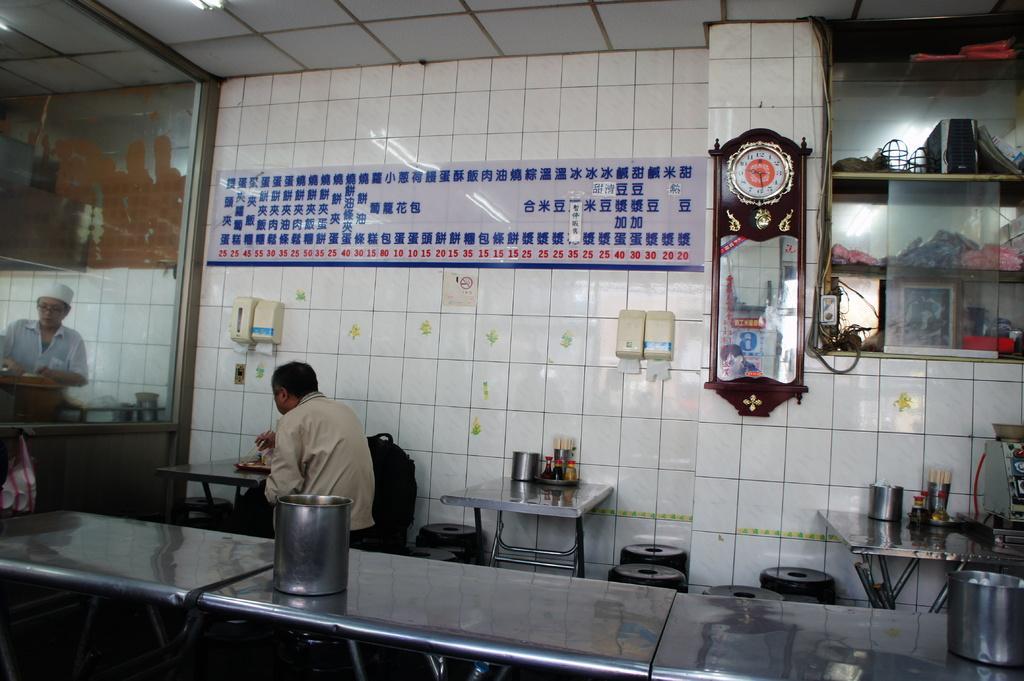In one or two sentences, can you explain what this image depicts? In this image, we can see some tables contains bottles and mugs. There is a person in the middle of the image sitting in front of the table beside the wall. There is a clock on the wall. There is cupboard in the top right of the image. There is an another person on the left side of the image. There is a ceiling at the top of the of the image. 